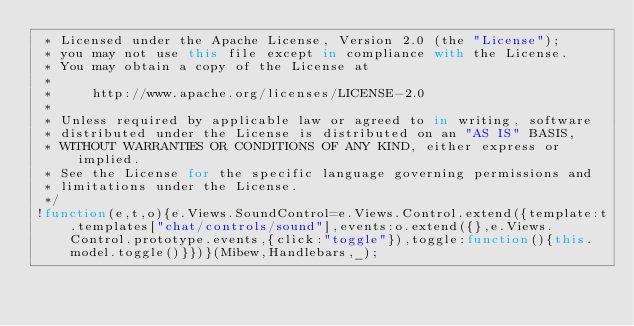<code> <loc_0><loc_0><loc_500><loc_500><_JavaScript_> * Licensed under the Apache License, Version 2.0 (the "License");
 * you may not use this file except in compliance with the License.
 * You may obtain a copy of the License at
 *
 *     http://www.apache.org/licenses/LICENSE-2.0
 *
 * Unless required by applicable law or agreed to in writing, software
 * distributed under the License is distributed on an "AS IS" BASIS,
 * WITHOUT WARRANTIES OR CONDITIONS OF ANY KIND, either express or implied.
 * See the License for the specific language governing permissions and
 * limitations under the License.
 */
!function(e,t,o){e.Views.SoundControl=e.Views.Control.extend({template:t.templates["chat/controls/sound"],events:o.extend({},e.Views.Control.prototype.events,{click:"toggle"}),toggle:function(){this.model.toggle()}})}(Mibew,Handlebars,_);</code> 